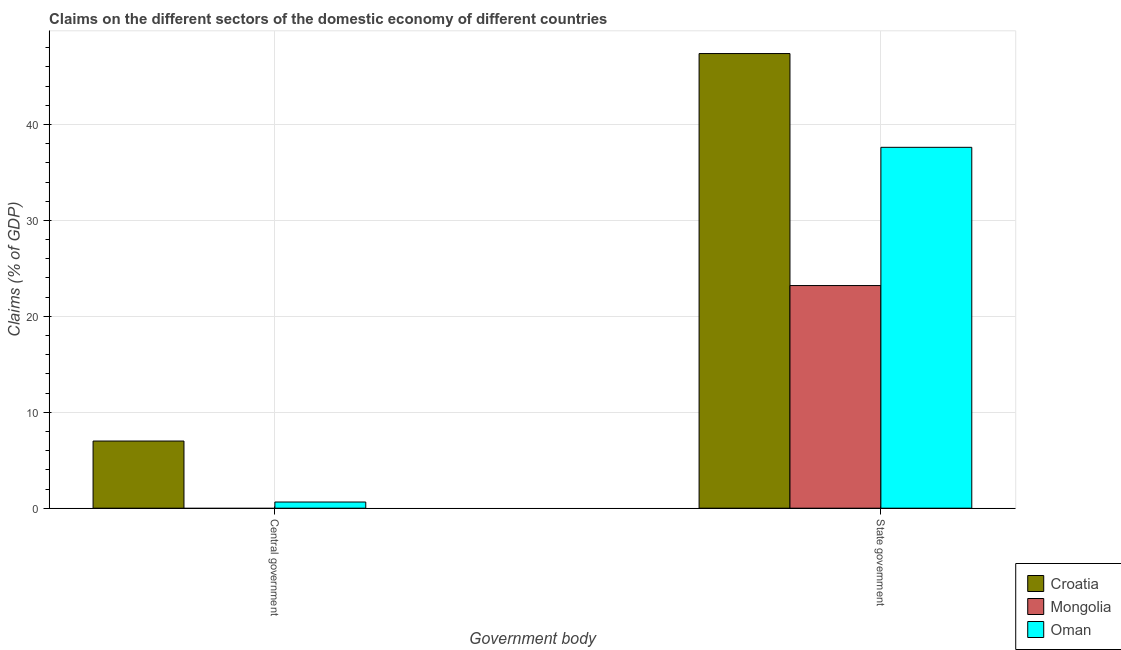How many different coloured bars are there?
Offer a terse response. 3. Are the number of bars on each tick of the X-axis equal?
Ensure brevity in your answer.  No. How many bars are there on the 1st tick from the left?
Make the answer very short. 2. How many bars are there on the 2nd tick from the right?
Offer a terse response. 2. What is the label of the 1st group of bars from the left?
Offer a very short reply. Central government. What is the claims on state government in Croatia?
Provide a succinct answer. 47.39. Across all countries, what is the maximum claims on central government?
Give a very brief answer. 7. In which country was the claims on state government maximum?
Your answer should be compact. Croatia. What is the total claims on central government in the graph?
Provide a succinct answer. 7.64. What is the difference between the claims on central government in Oman and that in Croatia?
Offer a terse response. -6.36. What is the difference between the claims on central government in Oman and the claims on state government in Mongolia?
Your answer should be compact. -22.56. What is the average claims on state government per country?
Offer a very short reply. 36.07. What is the difference between the claims on central government and claims on state government in Oman?
Your answer should be compact. -36.97. In how many countries, is the claims on state government greater than 40 %?
Make the answer very short. 1. What is the ratio of the claims on state government in Croatia to that in Oman?
Your response must be concise. 1.26. Is the claims on state government in Croatia less than that in Mongolia?
Your answer should be very brief. No. In how many countries, is the claims on central government greater than the average claims on central government taken over all countries?
Your response must be concise. 1. How many bars are there?
Provide a short and direct response. 5. How many countries are there in the graph?
Keep it short and to the point. 3. Are the values on the major ticks of Y-axis written in scientific E-notation?
Keep it short and to the point. No. Does the graph contain grids?
Offer a terse response. Yes. Where does the legend appear in the graph?
Your response must be concise. Bottom right. How many legend labels are there?
Keep it short and to the point. 3. What is the title of the graph?
Your answer should be compact. Claims on the different sectors of the domestic economy of different countries. Does "Turkey" appear as one of the legend labels in the graph?
Offer a terse response. No. What is the label or title of the X-axis?
Your answer should be very brief. Government body. What is the label or title of the Y-axis?
Ensure brevity in your answer.  Claims (% of GDP). What is the Claims (% of GDP) in Croatia in Central government?
Make the answer very short. 7. What is the Claims (% of GDP) in Mongolia in Central government?
Offer a very short reply. 0. What is the Claims (% of GDP) in Oman in Central government?
Offer a very short reply. 0.64. What is the Claims (% of GDP) of Croatia in State government?
Keep it short and to the point. 47.39. What is the Claims (% of GDP) of Mongolia in State government?
Keep it short and to the point. 23.21. What is the Claims (% of GDP) of Oman in State government?
Your response must be concise. 37.62. Across all Government body, what is the maximum Claims (% of GDP) in Croatia?
Give a very brief answer. 47.39. Across all Government body, what is the maximum Claims (% of GDP) of Mongolia?
Offer a terse response. 23.21. Across all Government body, what is the maximum Claims (% of GDP) in Oman?
Keep it short and to the point. 37.62. Across all Government body, what is the minimum Claims (% of GDP) in Croatia?
Provide a short and direct response. 7. Across all Government body, what is the minimum Claims (% of GDP) of Oman?
Your answer should be compact. 0.64. What is the total Claims (% of GDP) in Croatia in the graph?
Your answer should be very brief. 54.39. What is the total Claims (% of GDP) of Mongolia in the graph?
Keep it short and to the point. 23.21. What is the total Claims (% of GDP) of Oman in the graph?
Provide a succinct answer. 38.26. What is the difference between the Claims (% of GDP) of Croatia in Central government and that in State government?
Provide a succinct answer. -40.39. What is the difference between the Claims (% of GDP) in Oman in Central government and that in State government?
Offer a very short reply. -36.97. What is the difference between the Claims (% of GDP) of Croatia in Central government and the Claims (% of GDP) of Mongolia in State government?
Offer a terse response. -16.21. What is the difference between the Claims (% of GDP) in Croatia in Central government and the Claims (% of GDP) in Oman in State government?
Provide a succinct answer. -30.62. What is the average Claims (% of GDP) in Croatia per Government body?
Provide a short and direct response. 27.2. What is the average Claims (% of GDP) in Mongolia per Government body?
Your answer should be compact. 11.6. What is the average Claims (% of GDP) in Oman per Government body?
Keep it short and to the point. 19.13. What is the difference between the Claims (% of GDP) in Croatia and Claims (% of GDP) in Oman in Central government?
Your response must be concise. 6.36. What is the difference between the Claims (% of GDP) of Croatia and Claims (% of GDP) of Mongolia in State government?
Give a very brief answer. 24.18. What is the difference between the Claims (% of GDP) of Croatia and Claims (% of GDP) of Oman in State government?
Provide a succinct answer. 9.77. What is the difference between the Claims (% of GDP) in Mongolia and Claims (% of GDP) in Oman in State government?
Your answer should be very brief. -14.41. What is the ratio of the Claims (% of GDP) of Croatia in Central government to that in State government?
Offer a terse response. 0.15. What is the ratio of the Claims (% of GDP) of Oman in Central government to that in State government?
Your answer should be compact. 0.02. What is the difference between the highest and the second highest Claims (% of GDP) in Croatia?
Provide a succinct answer. 40.39. What is the difference between the highest and the second highest Claims (% of GDP) in Oman?
Offer a terse response. 36.97. What is the difference between the highest and the lowest Claims (% of GDP) in Croatia?
Provide a short and direct response. 40.39. What is the difference between the highest and the lowest Claims (% of GDP) of Mongolia?
Your answer should be compact. 23.21. What is the difference between the highest and the lowest Claims (% of GDP) of Oman?
Ensure brevity in your answer.  36.97. 